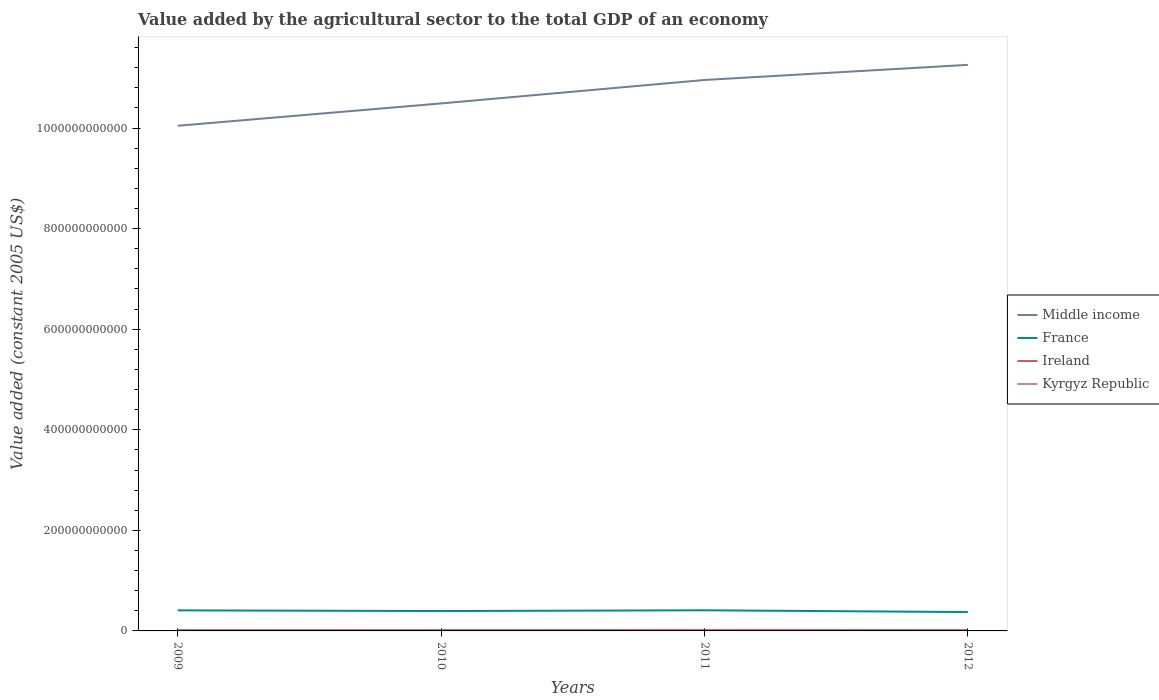How many different coloured lines are there?
Offer a terse response. 4. Does the line corresponding to Middle income intersect with the line corresponding to Kyrgyz Republic?
Your answer should be compact. No. Across all years, what is the maximum value added by the agricultural sector in Middle income?
Keep it short and to the point. 1.00e+12. What is the total value added by the agricultural sector in Middle income in the graph?
Your answer should be compact. -7.67e+1. What is the difference between the highest and the second highest value added by the agricultural sector in Kyrgyz Republic?
Your answer should be compact. 2.08e+07. What is the difference between the highest and the lowest value added by the agricultural sector in Kyrgyz Republic?
Offer a very short reply. 2. What is the difference between two consecutive major ticks on the Y-axis?
Make the answer very short. 2.00e+11. Are the values on the major ticks of Y-axis written in scientific E-notation?
Make the answer very short. No. Does the graph contain any zero values?
Offer a very short reply. No. Does the graph contain grids?
Keep it short and to the point. No. Where does the legend appear in the graph?
Your response must be concise. Center right. How many legend labels are there?
Give a very brief answer. 4. How are the legend labels stacked?
Keep it short and to the point. Vertical. What is the title of the graph?
Keep it short and to the point. Value added by the agricultural sector to the total GDP of an economy. Does "Tajikistan" appear as one of the legend labels in the graph?
Ensure brevity in your answer.  No. What is the label or title of the X-axis?
Provide a short and direct response. Years. What is the label or title of the Y-axis?
Provide a short and direct response. Value added (constant 2005 US$). What is the Value added (constant 2005 US$) of Middle income in 2009?
Offer a very short reply. 1.00e+12. What is the Value added (constant 2005 US$) of France in 2009?
Your response must be concise. 4.09e+1. What is the Value added (constant 2005 US$) of Ireland in 2009?
Offer a very short reply. 1.74e+09. What is the Value added (constant 2005 US$) in Kyrgyz Republic in 2009?
Provide a short and direct response. 6.86e+08. What is the Value added (constant 2005 US$) of Middle income in 2010?
Provide a succinct answer. 1.05e+12. What is the Value added (constant 2005 US$) of France in 2010?
Your response must be concise. 3.95e+1. What is the Value added (constant 2005 US$) of Ireland in 2010?
Make the answer very short. 1.74e+09. What is the Value added (constant 2005 US$) of Kyrgyz Republic in 2010?
Provide a succinct answer. 6.68e+08. What is the Value added (constant 2005 US$) of Middle income in 2011?
Provide a short and direct response. 1.10e+12. What is the Value added (constant 2005 US$) of France in 2011?
Your answer should be very brief. 4.10e+1. What is the Value added (constant 2005 US$) of Ireland in 2011?
Your answer should be compact. 2.01e+09. What is the Value added (constant 2005 US$) of Kyrgyz Republic in 2011?
Give a very brief answer. 6.80e+08. What is the Value added (constant 2005 US$) in Middle income in 2012?
Provide a succinct answer. 1.13e+12. What is the Value added (constant 2005 US$) in France in 2012?
Provide a short and direct response. 3.75e+1. What is the Value added (constant 2005 US$) of Ireland in 2012?
Offer a very short reply. 1.87e+09. What is the Value added (constant 2005 US$) in Kyrgyz Republic in 2012?
Offer a very short reply. 6.89e+08. Across all years, what is the maximum Value added (constant 2005 US$) of Middle income?
Ensure brevity in your answer.  1.13e+12. Across all years, what is the maximum Value added (constant 2005 US$) of France?
Offer a terse response. 4.10e+1. Across all years, what is the maximum Value added (constant 2005 US$) of Ireland?
Offer a terse response. 2.01e+09. Across all years, what is the maximum Value added (constant 2005 US$) of Kyrgyz Republic?
Your answer should be compact. 6.89e+08. Across all years, what is the minimum Value added (constant 2005 US$) in Middle income?
Your answer should be very brief. 1.00e+12. Across all years, what is the minimum Value added (constant 2005 US$) of France?
Offer a terse response. 3.75e+1. Across all years, what is the minimum Value added (constant 2005 US$) in Ireland?
Offer a terse response. 1.74e+09. Across all years, what is the minimum Value added (constant 2005 US$) in Kyrgyz Republic?
Your answer should be very brief. 6.68e+08. What is the total Value added (constant 2005 US$) in Middle income in the graph?
Offer a very short reply. 4.27e+12. What is the total Value added (constant 2005 US$) of France in the graph?
Your response must be concise. 1.59e+11. What is the total Value added (constant 2005 US$) in Ireland in the graph?
Ensure brevity in your answer.  7.36e+09. What is the total Value added (constant 2005 US$) of Kyrgyz Republic in the graph?
Ensure brevity in your answer.  2.72e+09. What is the difference between the Value added (constant 2005 US$) of Middle income in 2009 and that in 2010?
Your response must be concise. -4.44e+1. What is the difference between the Value added (constant 2005 US$) in France in 2009 and that in 2010?
Offer a very short reply. 1.38e+09. What is the difference between the Value added (constant 2005 US$) of Ireland in 2009 and that in 2010?
Give a very brief answer. -3.42e+06. What is the difference between the Value added (constant 2005 US$) of Kyrgyz Republic in 2009 and that in 2010?
Provide a short and direct response. 1.76e+07. What is the difference between the Value added (constant 2005 US$) in Middle income in 2009 and that in 2011?
Keep it short and to the point. -9.10e+1. What is the difference between the Value added (constant 2005 US$) in France in 2009 and that in 2011?
Provide a short and direct response. -1.64e+08. What is the difference between the Value added (constant 2005 US$) in Ireland in 2009 and that in 2011?
Offer a terse response. -2.67e+08. What is the difference between the Value added (constant 2005 US$) of Kyrgyz Republic in 2009 and that in 2011?
Provide a short and direct response. 5.31e+06. What is the difference between the Value added (constant 2005 US$) in Middle income in 2009 and that in 2012?
Offer a very short reply. -1.21e+11. What is the difference between the Value added (constant 2005 US$) in France in 2009 and that in 2012?
Your answer should be very brief. 3.38e+09. What is the difference between the Value added (constant 2005 US$) of Ireland in 2009 and that in 2012?
Make the answer very short. -1.28e+08. What is the difference between the Value added (constant 2005 US$) of Kyrgyz Republic in 2009 and that in 2012?
Offer a terse response. -3.17e+06. What is the difference between the Value added (constant 2005 US$) of Middle income in 2010 and that in 2011?
Your answer should be very brief. -4.66e+1. What is the difference between the Value added (constant 2005 US$) in France in 2010 and that in 2011?
Make the answer very short. -1.54e+09. What is the difference between the Value added (constant 2005 US$) in Ireland in 2010 and that in 2011?
Give a very brief answer. -2.63e+08. What is the difference between the Value added (constant 2005 US$) of Kyrgyz Republic in 2010 and that in 2011?
Keep it short and to the point. -1.23e+07. What is the difference between the Value added (constant 2005 US$) of Middle income in 2010 and that in 2012?
Provide a succinct answer. -7.67e+1. What is the difference between the Value added (constant 2005 US$) in France in 2010 and that in 2012?
Your answer should be compact. 2.00e+09. What is the difference between the Value added (constant 2005 US$) of Ireland in 2010 and that in 2012?
Offer a terse response. -1.24e+08. What is the difference between the Value added (constant 2005 US$) in Kyrgyz Republic in 2010 and that in 2012?
Make the answer very short. -2.08e+07. What is the difference between the Value added (constant 2005 US$) of Middle income in 2011 and that in 2012?
Ensure brevity in your answer.  -3.01e+1. What is the difference between the Value added (constant 2005 US$) of France in 2011 and that in 2012?
Provide a succinct answer. 3.54e+09. What is the difference between the Value added (constant 2005 US$) in Ireland in 2011 and that in 2012?
Offer a terse response. 1.39e+08. What is the difference between the Value added (constant 2005 US$) of Kyrgyz Republic in 2011 and that in 2012?
Your response must be concise. -8.48e+06. What is the difference between the Value added (constant 2005 US$) of Middle income in 2009 and the Value added (constant 2005 US$) of France in 2010?
Your response must be concise. 9.65e+11. What is the difference between the Value added (constant 2005 US$) in Middle income in 2009 and the Value added (constant 2005 US$) in Ireland in 2010?
Ensure brevity in your answer.  1.00e+12. What is the difference between the Value added (constant 2005 US$) of Middle income in 2009 and the Value added (constant 2005 US$) of Kyrgyz Republic in 2010?
Your response must be concise. 1.00e+12. What is the difference between the Value added (constant 2005 US$) of France in 2009 and the Value added (constant 2005 US$) of Ireland in 2010?
Offer a very short reply. 3.91e+1. What is the difference between the Value added (constant 2005 US$) in France in 2009 and the Value added (constant 2005 US$) in Kyrgyz Republic in 2010?
Ensure brevity in your answer.  4.02e+1. What is the difference between the Value added (constant 2005 US$) in Ireland in 2009 and the Value added (constant 2005 US$) in Kyrgyz Republic in 2010?
Offer a very short reply. 1.07e+09. What is the difference between the Value added (constant 2005 US$) in Middle income in 2009 and the Value added (constant 2005 US$) in France in 2011?
Your answer should be compact. 9.64e+11. What is the difference between the Value added (constant 2005 US$) in Middle income in 2009 and the Value added (constant 2005 US$) in Ireland in 2011?
Provide a succinct answer. 1.00e+12. What is the difference between the Value added (constant 2005 US$) in Middle income in 2009 and the Value added (constant 2005 US$) in Kyrgyz Republic in 2011?
Your answer should be very brief. 1.00e+12. What is the difference between the Value added (constant 2005 US$) in France in 2009 and the Value added (constant 2005 US$) in Ireland in 2011?
Provide a short and direct response. 3.89e+1. What is the difference between the Value added (constant 2005 US$) in France in 2009 and the Value added (constant 2005 US$) in Kyrgyz Republic in 2011?
Give a very brief answer. 4.02e+1. What is the difference between the Value added (constant 2005 US$) of Ireland in 2009 and the Value added (constant 2005 US$) of Kyrgyz Republic in 2011?
Keep it short and to the point. 1.06e+09. What is the difference between the Value added (constant 2005 US$) of Middle income in 2009 and the Value added (constant 2005 US$) of France in 2012?
Make the answer very short. 9.67e+11. What is the difference between the Value added (constant 2005 US$) in Middle income in 2009 and the Value added (constant 2005 US$) in Ireland in 2012?
Provide a short and direct response. 1.00e+12. What is the difference between the Value added (constant 2005 US$) in Middle income in 2009 and the Value added (constant 2005 US$) in Kyrgyz Republic in 2012?
Provide a short and direct response. 1.00e+12. What is the difference between the Value added (constant 2005 US$) in France in 2009 and the Value added (constant 2005 US$) in Ireland in 2012?
Offer a very short reply. 3.90e+1. What is the difference between the Value added (constant 2005 US$) of France in 2009 and the Value added (constant 2005 US$) of Kyrgyz Republic in 2012?
Provide a succinct answer. 4.02e+1. What is the difference between the Value added (constant 2005 US$) in Ireland in 2009 and the Value added (constant 2005 US$) in Kyrgyz Republic in 2012?
Offer a very short reply. 1.05e+09. What is the difference between the Value added (constant 2005 US$) in Middle income in 2010 and the Value added (constant 2005 US$) in France in 2011?
Keep it short and to the point. 1.01e+12. What is the difference between the Value added (constant 2005 US$) of Middle income in 2010 and the Value added (constant 2005 US$) of Ireland in 2011?
Provide a succinct answer. 1.05e+12. What is the difference between the Value added (constant 2005 US$) of Middle income in 2010 and the Value added (constant 2005 US$) of Kyrgyz Republic in 2011?
Give a very brief answer. 1.05e+12. What is the difference between the Value added (constant 2005 US$) in France in 2010 and the Value added (constant 2005 US$) in Ireland in 2011?
Your answer should be very brief. 3.75e+1. What is the difference between the Value added (constant 2005 US$) in France in 2010 and the Value added (constant 2005 US$) in Kyrgyz Republic in 2011?
Make the answer very short. 3.88e+1. What is the difference between the Value added (constant 2005 US$) of Ireland in 2010 and the Value added (constant 2005 US$) of Kyrgyz Republic in 2011?
Your response must be concise. 1.06e+09. What is the difference between the Value added (constant 2005 US$) in Middle income in 2010 and the Value added (constant 2005 US$) in France in 2012?
Provide a succinct answer. 1.01e+12. What is the difference between the Value added (constant 2005 US$) of Middle income in 2010 and the Value added (constant 2005 US$) of Ireland in 2012?
Keep it short and to the point. 1.05e+12. What is the difference between the Value added (constant 2005 US$) of Middle income in 2010 and the Value added (constant 2005 US$) of Kyrgyz Republic in 2012?
Offer a terse response. 1.05e+12. What is the difference between the Value added (constant 2005 US$) in France in 2010 and the Value added (constant 2005 US$) in Ireland in 2012?
Provide a short and direct response. 3.76e+1. What is the difference between the Value added (constant 2005 US$) of France in 2010 and the Value added (constant 2005 US$) of Kyrgyz Republic in 2012?
Provide a short and direct response. 3.88e+1. What is the difference between the Value added (constant 2005 US$) of Ireland in 2010 and the Value added (constant 2005 US$) of Kyrgyz Republic in 2012?
Ensure brevity in your answer.  1.05e+09. What is the difference between the Value added (constant 2005 US$) in Middle income in 2011 and the Value added (constant 2005 US$) in France in 2012?
Give a very brief answer. 1.06e+12. What is the difference between the Value added (constant 2005 US$) of Middle income in 2011 and the Value added (constant 2005 US$) of Ireland in 2012?
Give a very brief answer. 1.09e+12. What is the difference between the Value added (constant 2005 US$) in Middle income in 2011 and the Value added (constant 2005 US$) in Kyrgyz Republic in 2012?
Your response must be concise. 1.09e+12. What is the difference between the Value added (constant 2005 US$) in France in 2011 and the Value added (constant 2005 US$) in Ireland in 2012?
Your answer should be very brief. 3.92e+1. What is the difference between the Value added (constant 2005 US$) of France in 2011 and the Value added (constant 2005 US$) of Kyrgyz Republic in 2012?
Your answer should be compact. 4.04e+1. What is the difference between the Value added (constant 2005 US$) of Ireland in 2011 and the Value added (constant 2005 US$) of Kyrgyz Republic in 2012?
Provide a short and direct response. 1.32e+09. What is the average Value added (constant 2005 US$) of Middle income per year?
Keep it short and to the point. 1.07e+12. What is the average Value added (constant 2005 US$) in France per year?
Your answer should be compact. 3.97e+1. What is the average Value added (constant 2005 US$) in Ireland per year?
Provide a short and direct response. 1.84e+09. What is the average Value added (constant 2005 US$) in Kyrgyz Republic per year?
Offer a terse response. 6.81e+08. In the year 2009, what is the difference between the Value added (constant 2005 US$) of Middle income and Value added (constant 2005 US$) of France?
Make the answer very short. 9.64e+11. In the year 2009, what is the difference between the Value added (constant 2005 US$) in Middle income and Value added (constant 2005 US$) in Ireland?
Make the answer very short. 1.00e+12. In the year 2009, what is the difference between the Value added (constant 2005 US$) of Middle income and Value added (constant 2005 US$) of Kyrgyz Republic?
Make the answer very short. 1.00e+12. In the year 2009, what is the difference between the Value added (constant 2005 US$) of France and Value added (constant 2005 US$) of Ireland?
Your response must be concise. 3.91e+1. In the year 2009, what is the difference between the Value added (constant 2005 US$) in France and Value added (constant 2005 US$) in Kyrgyz Republic?
Keep it short and to the point. 4.02e+1. In the year 2009, what is the difference between the Value added (constant 2005 US$) in Ireland and Value added (constant 2005 US$) in Kyrgyz Republic?
Provide a short and direct response. 1.05e+09. In the year 2010, what is the difference between the Value added (constant 2005 US$) of Middle income and Value added (constant 2005 US$) of France?
Ensure brevity in your answer.  1.01e+12. In the year 2010, what is the difference between the Value added (constant 2005 US$) in Middle income and Value added (constant 2005 US$) in Ireland?
Ensure brevity in your answer.  1.05e+12. In the year 2010, what is the difference between the Value added (constant 2005 US$) of Middle income and Value added (constant 2005 US$) of Kyrgyz Republic?
Keep it short and to the point. 1.05e+12. In the year 2010, what is the difference between the Value added (constant 2005 US$) in France and Value added (constant 2005 US$) in Ireland?
Keep it short and to the point. 3.78e+1. In the year 2010, what is the difference between the Value added (constant 2005 US$) in France and Value added (constant 2005 US$) in Kyrgyz Republic?
Your response must be concise. 3.88e+1. In the year 2010, what is the difference between the Value added (constant 2005 US$) of Ireland and Value added (constant 2005 US$) of Kyrgyz Republic?
Your response must be concise. 1.08e+09. In the year 2011, what is the difference between the Value added (constant 2005 US$) of Middle income and Value added (constant 2005 US$) of France?
Your answer should be compact. 1.05e+12. In the year 2011, what is the difference between the Value added (constant 2005 US$) in Middle income and Value added (constant 2005 US$) in Ireland?
Offer a terse response. 1.09e+12. In the year 2011, what is the difference between the Value added (constant 2005 US$) in Middle income and Value added (constant 2005 US$) in Kyrgyz Republic?
Your answer should be very brief. 1.09e+12. In the year 2011, what is the difference between the Value added (constant 2005 US$) of France and Value added (constant 2005 US$) of Ireland?
Ensure brevity in your answer.  3.90e+1. In the year 2011, what is the difference between the Value added (constant 2005 US$) of France and Value added (constant 2005 US$) of Kyrgyz Republic?
Your answer should be compact. 4.04e+1. In the year 2011, what is the difference between the Value added (constant 2005 US$) in Ireland and Value added (constant 2005 US$) in Kyrgyz Republic?
Offer a very short reply. 1.33e+09. In the year 2012, what is the difference between the Value added (constant 2005 US$) in Middle income and Value added (constant 2005 US$) in France?
Give a very brief answer. 1.09e+12. In the year 2012, what is the difference between the Value added (constant 2005 US$) of Middle income and Value added (constant 2005 US$) of Ireland?
Keep it short and to the point. 1.12e+12. In the year 2012, what is the difference between the Value added (constant 2005 US$) of Middle income and Value added (constant 2005 US$) of Kyrgyz Republic?
Your answer should be compact. 1.12e+12. In the year 2012, what is the difference between the Value added (constant 2005 US$) in France and Value added (constant 2005 US$) in Ireland?
Your answer should be very brief. 3.56e+1. In the year 2012, what is the difference between the Value added (constant 2005 US$) of France and Value added (constant 2005 US$) of Kyrgyz Republic?
Offer a terse response. 3.68e+1. In the year 2012, what is the difference between the Value added (constant 2005 US$) of Ireland and Value added (constant 2005 US$) of Kyrgyz Republic?
Ensure brevity in your answer.  1.18e+09. What is the ratio of the Value added (constant 2005 US$) of Middle income in 2009 to that in 2010?
Your answer should be compact. 0.96. What is the ratio of the Value added (constant 2005 US$) of France in 2009 to that in 2010?
Give a very brief answer. 1.03. What is the ratio of the Value added (constant 2005 US$) in Kyrgyz Republic in 2009 to that in 2010?
Your answer should be compact. 1.03. What is the ratio of the Value added (constant 2005 US$) in Middle income in 2009 to that in 2011?
Give a very brief answer. 0.92. What is the ratio of the Value added (constant 2005 US$) of Ireland in 2009 to that in 2011?
Keep it short and to the point. 0.87. What is the ratio of the Value added (constant 2005 US$) of Kyrgyz Republic in 2009 to that in 2011?
Provide a short and direct response. 1.01. What is the ratio of the Value added (constant 2005 US$) in Middle income in 2009 to that in 2012?
Provide a succinct answer. 0.89. What is the ratio of the Value added (constant 2005 US$) in France in 2009 to that in 2012?
Your answer should be very brief. 1.09. What is the ratio of the Value added (constant 2005 US$) of Ireland in 2009 to that in 2012?
Your answer should be very brief. 0.93. What is the ratio of the Value added (constant 2005 US$) of Kyrgyz Republic in 2009 to that in 2012?
Keep it short and to the point. 1. What is the ratio of the Value added (constant 2005 US$) in Middle income in 2010 to that in 2011?
Provide a succinct answer. 0.96. What is the ratio of the Value added (constant 2005 US$) in France in 2010 to that in 2011?
Your answer should be very brief. 0.96. What is the ratio of the Value added (constant 2005 US$) in Ireland in 2010 to that in 2011?
Ensure brevity in your answer.  0.87. What is the ratio of the Value added (constant 2005 US$) in Kyrgyz Republic in 2010 to that in 2011?
Your answer should be compact. 0.98. What is the ratio of the Value added (constant 2005 US$) of Middle income in 2010 to that in 2012?
Your answer should be compact. 0.93. What is the ratio of the Value added (constant 2005 US$) of France in 2010 to that in 2012?
Offer a very short reply. 1.05. What is the ratio of the Value added (constant 2005 US$) in Ireland in 2010 to that in 2012?
Provide a succinct answer. 0.93. What is the ratio of the Value added (constant 2005 US$) in Kyrgyz Republic in 2010 to that in 2012?
Offer a terse response. 0.97. What is the ratio of the Value added (constant 2005 US$) of Middle income in 2011 to that in 2012?
Offer a very short reply. 0.97. What is the ratio of the Value added (constant 2005 US$) of France in 2011 to that in 2012?
Provide a succinct answer. 1.09. What is the ratio of the Value added (constant 2005 US$) of Ireland in 2011 to that in 2012?
Give a very brief answer. 1.07. What is the difference between the highest and the second highest Value added (constant 2005 US$) of Middle income?
Offer a terse response. 3.01e+1. What is the difference between the highest and the second highest Value added (constant 2005 US$) of France?
Keep it short and to the point. 1.64e+08. What is the difference between the highest and the second highest Value added (constant 2005 US$) in Ireland?
Your answer should be compact. 1.39e+08. What is the difference between the highest and the second highest Value added (constant 2005 US$) of Kyrgyz Republic?
Make the answer very short. 3.17e+06. What is the difference between the highest and the lowest Value added (constant 2005 US$) in Middle income?
Ensure brevity in your answer.  1.21e+11. What is the difference between the highest and the lowest Value added (constant 2005 US$) of France?
Keep it short and to the point. 3.54e+09. What is the difference between the highest and the lowest Value added (constant 2005 US$) of Ireland?
Your answer should be compact. 2.67e+08. What is the difference between the highest and the lowest Value added (constant 2005 US$) in Kyrgyz Republic?
Provide a succinct answer. 2.08e+07. 